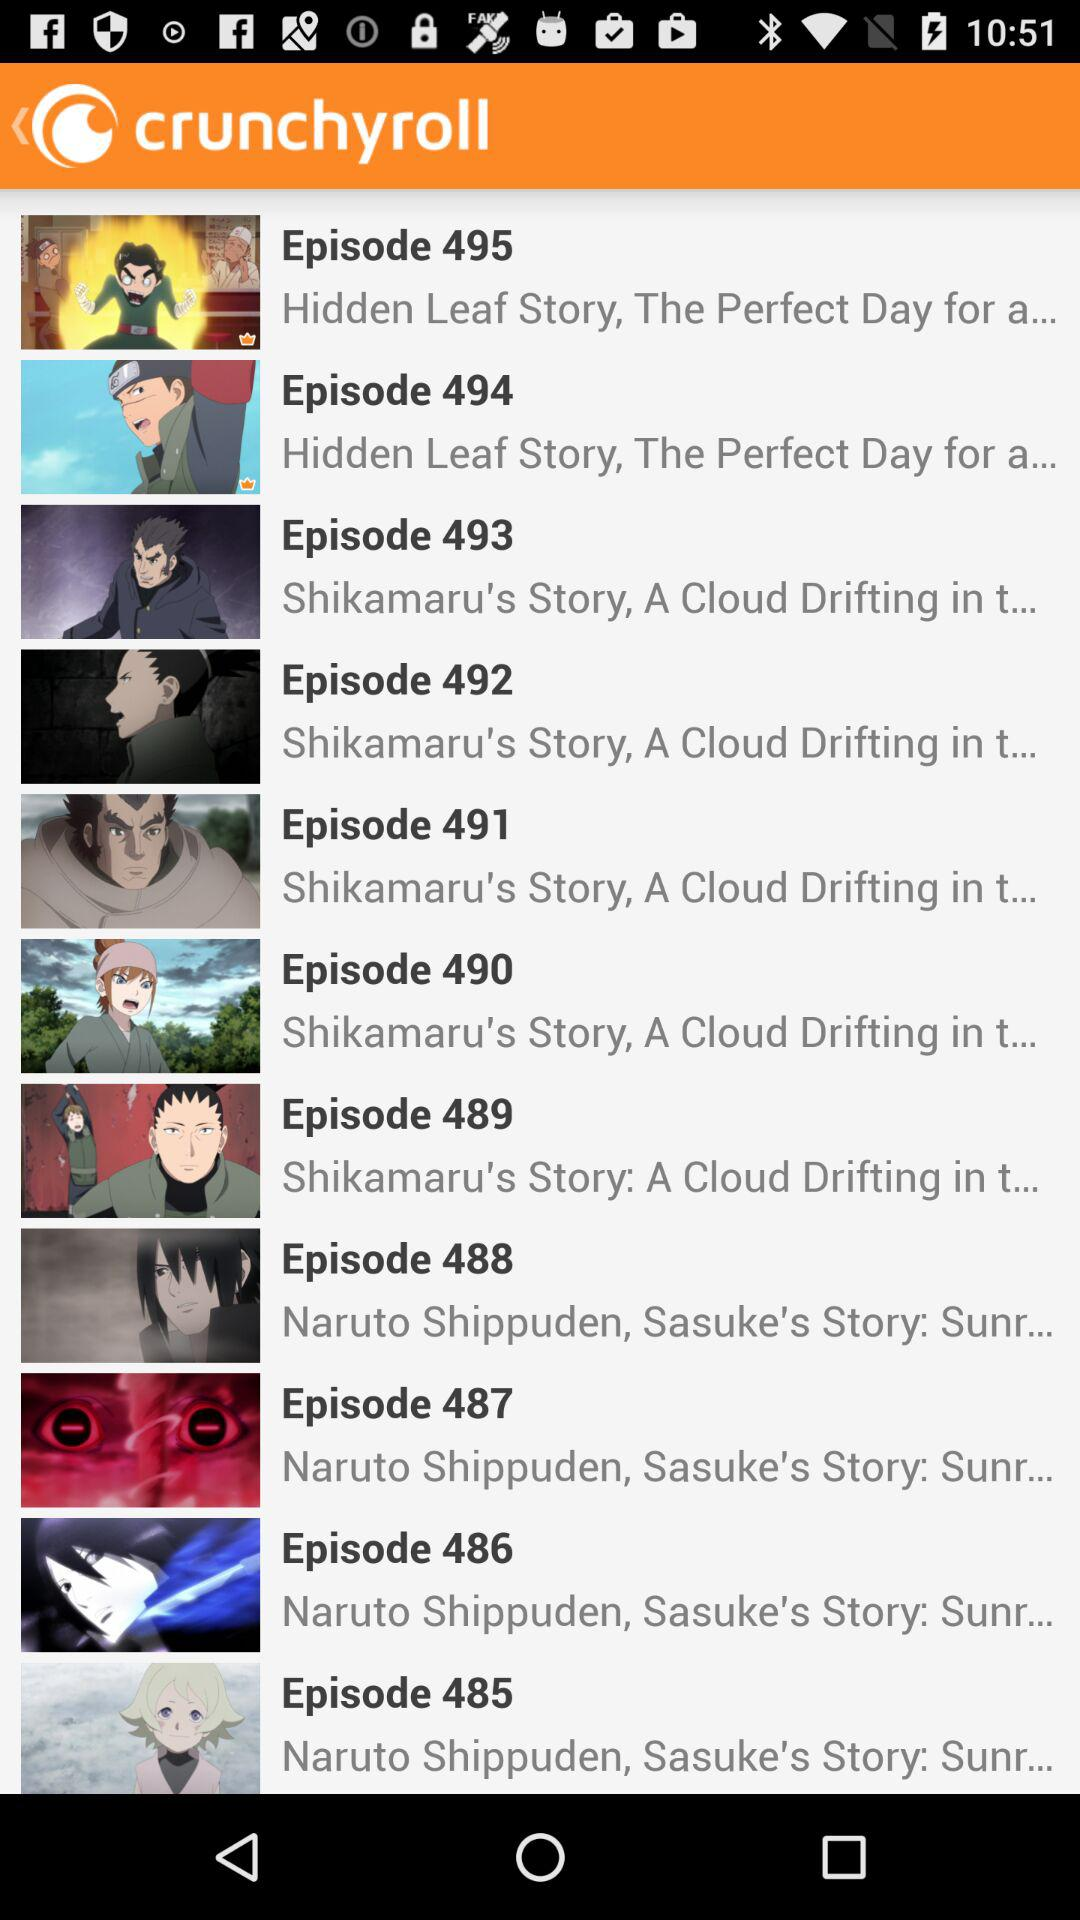What is the application name? The application name is "crunchyroll". 